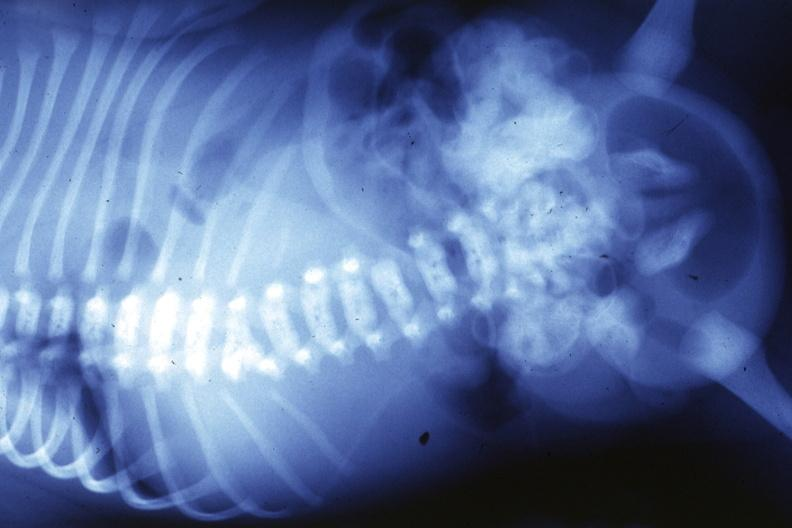what is present?
Answer the question using a single word or phrase. Joints 